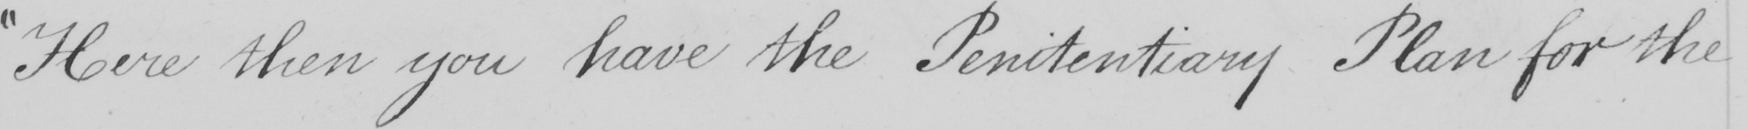Transcribe the text shown in this historical manuscript line. " Here then you have the Penitentiary Plan for the 